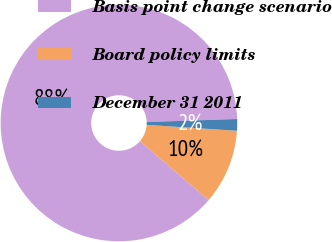Convert chart. <chart><loc_0><loc_0><loc_500><loc_500><pie_chart><fcel>Basis point change scenario<fcel>Board policy limits<fcel>December 31 2011<nl><fcel>88.17%<fcel>10.25%<fcel>1.59%<nl></chart> 